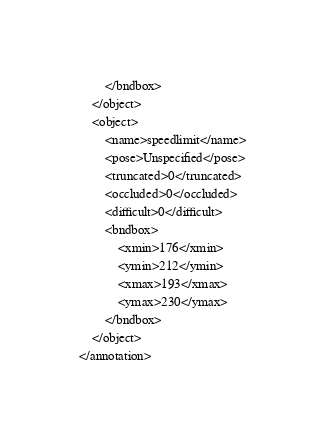<code> <loc_0><loc_0><loc_500><loc_500><_XML_>        </bndbox>
    </object>
    <object>
        <name>speedlimit</name>
        <pose>Unspecified</pose>
        <truncated>0</truncated>
        <occluded>0</occluded>
        <difficult>0</difficult>
        <bndbox>
            <xmin>176</xmin>
            <ymin>212</ymin>
            <xmax>193</xmax>
            <ymax>230</ymax>
        </bndbox>
    </object>
</annotation></code> 